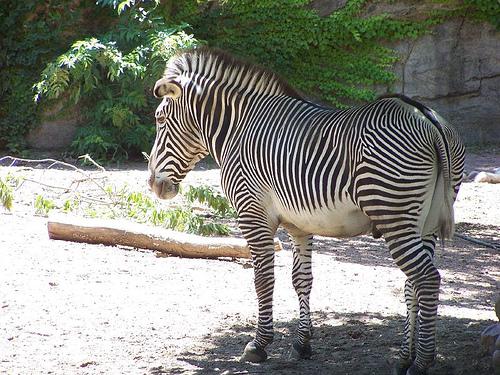Is the zebra in the shade?
Be succinct. Yes. Is there a log on the ground?
Keep it brief. Yes. Does the zebra have a tail?
Keep it brief. Yes. Is this a baby?
Short answer required. No. 